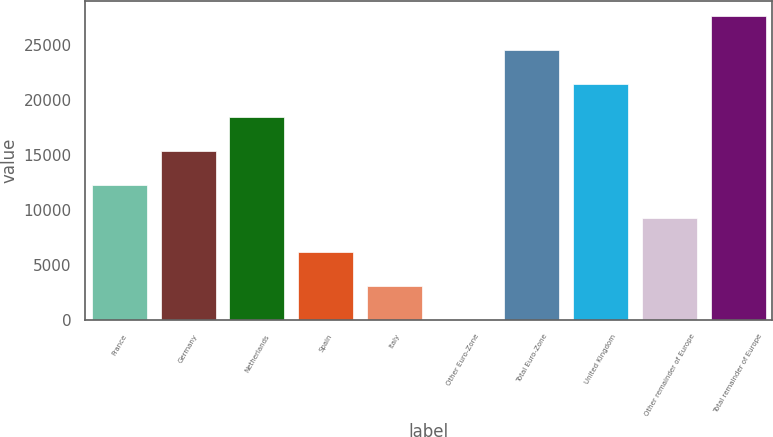Convert chart to OTSL. <chart><loc_0><loc_0><loc_500><loc_500><bar_chart><fcel>France<fcel>Germany<fcel>Netherlands<fcel>Spain<fcel>Italy<fcel>Other Euro-Zone<fcel>Total Euro-Zone<fcel>United Kingdom<fcel>Other remainder of Europe<fcel>Total remainder of Europe<nl><fcel>12280.8<fcel>15345.5<fcel>18410.2<fcel>6151.4<fcel>3086.7<fcel>22<fcel>24539.6<fcel>21474.9<fcel>9216.1<fcel>27604.3<nl></chart> 